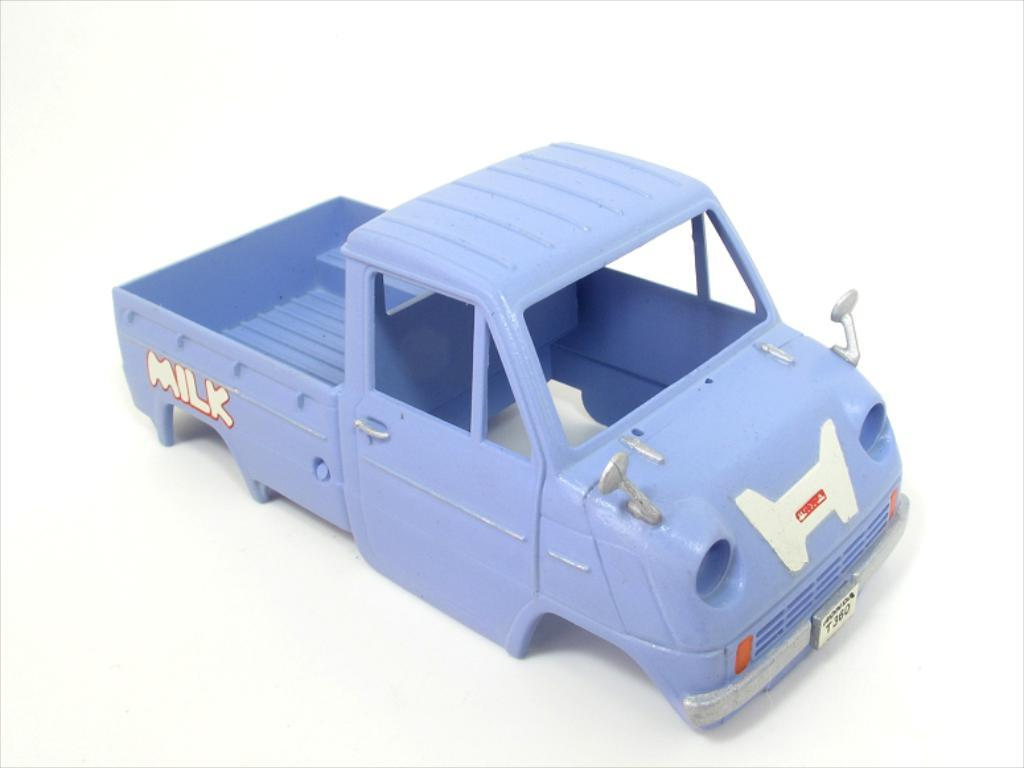What type of toy is present in the image? There is a toy vehicle in the image. What is unique about this toy vehicle? The toy vehicle has no tires and has glasses. Does the toy vehicle have any other features? Yes, the toy vehicle has lights. How is the toy vehicle designed to be used? The toy vehicle is meant to fit on a platform. What type of cake is being served on the platform where the toy vehicle is placed? There is no cake present in the image; it only features a toy vehicle with specific features and design. 